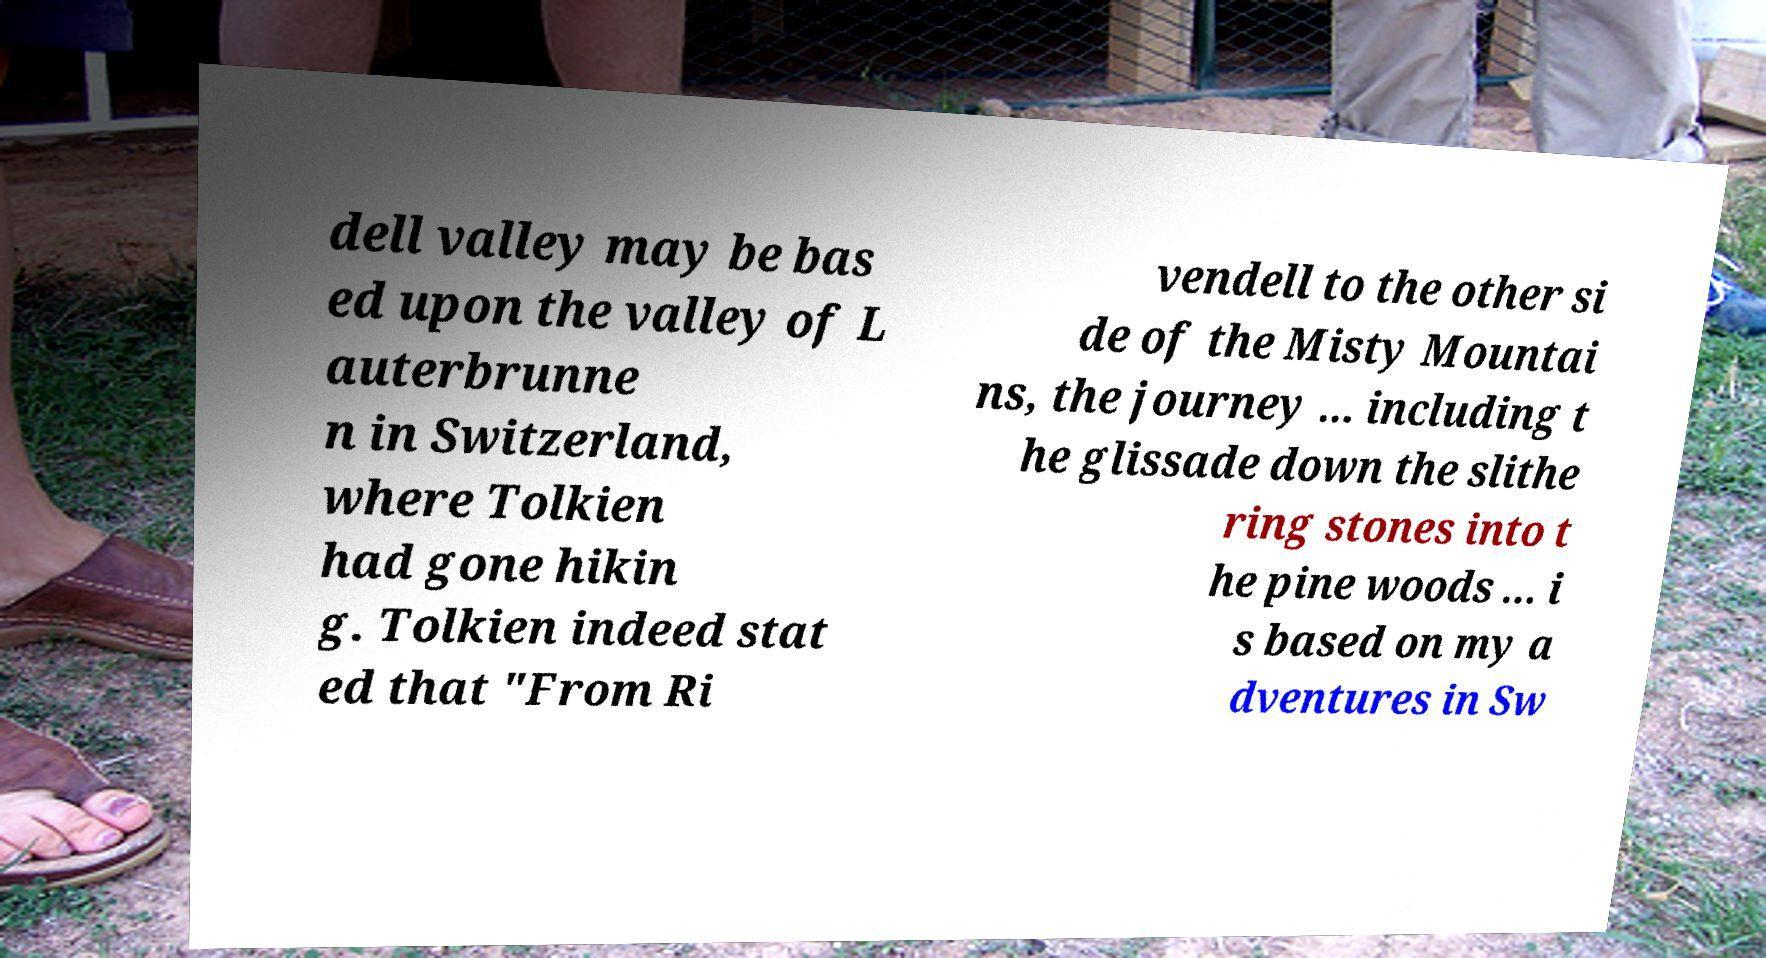Please read and relay the text visible in this image. What does it say? dell valley may be bas ed upon the valley of L auterbrunne n in Switzerland, where Tolkien had gone hikin g. Tolkien indeed stat ed that "From Ri vendell to the other si de of the Misty Mountai ns, the journey ... including t he glissade down the slithe ring stones into t he pine woods ... i s based on my a dventures in Sw 